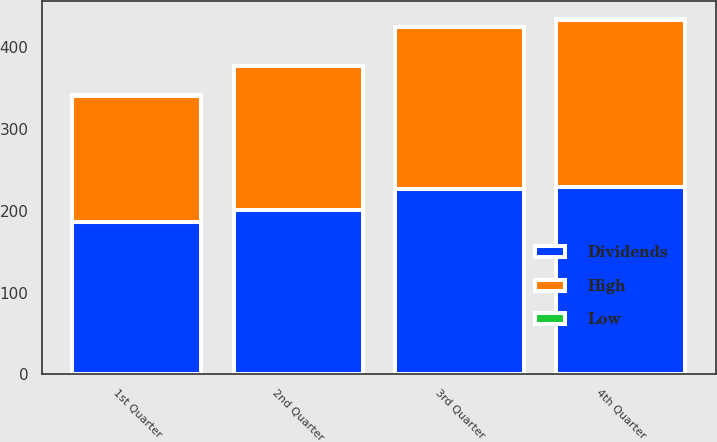Convert chart to OTSL. <chart><loc_0><loc_0><loc_500><loc_500><stacked_bar_chart><ecel><fcel>1st Quarter<fcel>2nd Quarter<fcel>3rd Quarter<fcel>4th Quarter<nl><fcel>Dividends<fcel>186.06<fcel>200.64<fcel>227.2<fcel>229.5<nl><fcel>High<fcel>155.11<fcel>176.21<fcel>197.32<fcel>204.6<nl><fcel>Low<fcel>0.52<fcel>0.52<fcel>0.52<fcel>0.52<nl></chart> 